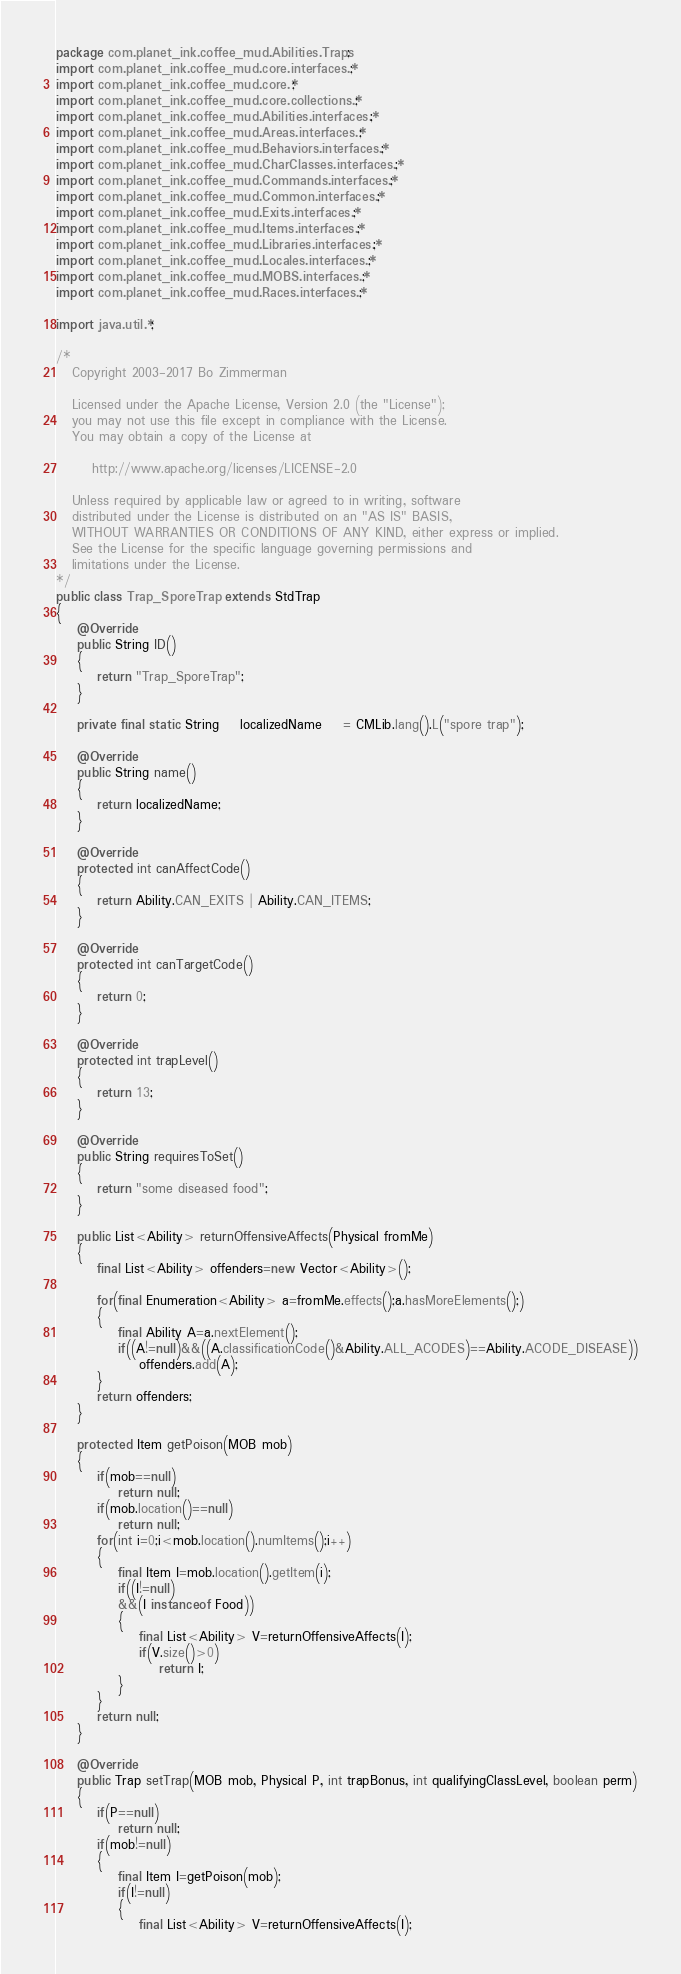<code> <loc_0><loc_0><loc_500><loc_500><_Java_>package com.planet_ink.coffee_mud.Abilities.Traps;
import com.planet_ink.coffee_mud.core.interfaces.*;
import com.planet_ink.coffee_mud.core.*;
import com.planet_ink.coffee_mud.core.collections.*;
import com.planet_ink.coffee_mud.Abilities.interfaces.*;
import com.planet_ink.coffee_mud.Areas.interfaces.*;
import com.planet_ink.coffee_mud.Behaviors.interfaces.*;
import com.planet_ink.coffee_mud.CharClasses.interfaces.*;
import com.planet_ink.coffee_mud.Commands.interfaces.*;
import com.planet_ink.coffee_mud.Common.interfaces.*;
import com.planet_ink.coffee_mud.Exits.interfaces.*;
import com.planet_ink.coffee_mud.Items.interfaces.*;
import com.planet_ink.coffee_mud.Libraries.interfaces.*;
import com.planet_ink.coffee_mud.Locales.interfaces.*;
import com.planet_ink.coffee_mud.MOBS.interfaces.*;
import com.planet_ink.coffee_mud.Races.interfaces.*;

import java.util.*;

/*
   Copyright 2003-2017 Bo Zimmerman

   Licensed under the Apache License, Version 2.0 (the "License");
   you may not use this file except in compliance with the License.
   You may obtain a copy of the License at

	   http://www.apache.org/licenses/LICENSE-2.0

   Unless required by applicable law or agreed to in writing, software
   distributed under the License is distributed on an "AS IS" BASIS,
   WITHOUT WARRANTIES OR CONDITIONS OF ANY KIND, either express or implied.
   See the License for the specific language governing permissions and
   limitations under the License.
*/
public class Trap_SporeTrap extends StdTrap
{
	@Override
	public String ID()
	{
		return "Trap_SporeTrap";
	}

	private final static String	localizedName	= CMLib.lang().L("spore trap");

	@Override
	public String name()
	{
		return localizedName;
	}

	@Override
	protected int canAffectCode()
	{
		return Ability.CAN_EXITS | Ability.CAN_ITEMS;
	}

	@Override
	protected int canTargetCode()
	{
		return 0;
	}

	@Override
	protected int trapLevel()
	{
		return 13;
	}

	@Override
	public String requiresToSet()
	{
		return "some diseased food";
	}

	public List<Ability> returnOffensiveAffects(Physical fromMe)
	{
		final List<Ability> offenders=new Vector<Ability>();

		for(final Enumeration<Ability> a=fromMe.effects();a.hasMoreElements();)
		{
			final Ability A=a.nextElement();
			if((A!=null)&&((A.classificationCode()&Ability.ALL_ACODES)==Ability.ACODE_DISEASE))
				offenders.add(A);
		}
		return offenders;
	}

	protected Item getPoison(MOB mob)
	{
		if(mob==null)
			return null;
		if(mob.location()==null)
			return null;
		for(int i=0;i<mob.location().numItems();i++)
		{
			final Item I=mob.location().getItem(i);
			if((I!=null)
			&&(I instanceof Food))
			{
				final List<Ability> V=returnOffensiveAffects(I);
				if(V.size()>0)
					return I;
			}
		}
		return null;
	}

	@Override
	public Trap setTrap(MOB mob, Physical P, int trapBonus, int qualifyingClassLevel, boolean perm)
	{
		if(P==null)
			return null;
		if(mob!=null)
		{
			final Item I=getPoison(mob);
			if(I!=null)
			{
				final List<Ability> V=returnOffensiveAffects(I);</code> 